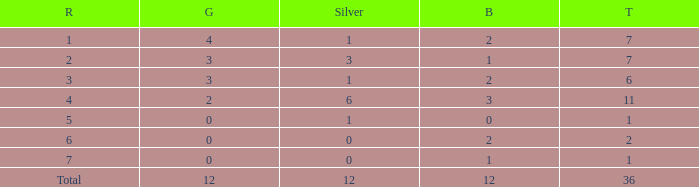What is the number of bronze medals when there are fewer than 0 silver medals? None. 